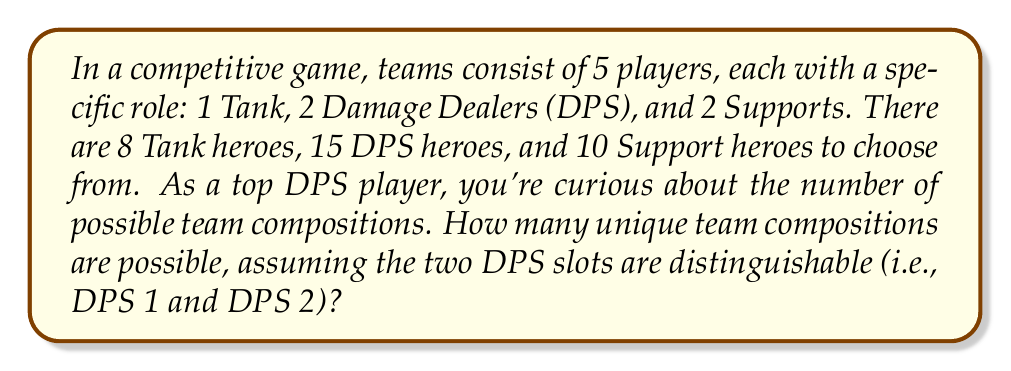Teach me how to tackle this problem. Let's break this down step-by-step:

1) First, let's consider each role separately:

   - For the Tank role: There are 8 choices.
   - For DPS 1: There are 15 choices.
   - For DPS 2: There are 14 choices (as one hero is already chosen for DPS 1).
   - For Support 1: There are 10 choices.
   - For Support 2: There are 9 choices (as one hero is already chosen for Support 1).

2) Now, we can apply the multiplication principle. The total number of possible team compositions is the product of the number of choices for each role:

   $$ 8 \times 15 \times 14 \times 10 \times 9 $$

3) Let's calculate this:

   $$ 8 \times 15 \times 14 \times 10 \times 9 = 151,200 $$

4) This can also be written as:

   $$ 8 \times \binom{15}{2} \times \binom{10}{2} \times 2! $$

   Where $\binom{15}{2}$ represents the number of ways to choose 2 DPS heroes from 15, $\binom{10}{2}$ represents the number of ways to choose 2 Support heroes from 10, and $2!$ accounts for the order of selection for both DPS and Support roles.

5) This formula gives us:

   $$ 8 \times 105 \times 45 \times 2 = 151,200 $$

Thus, there are 151,200 possible unique team compositions.
Answer: 151,200 